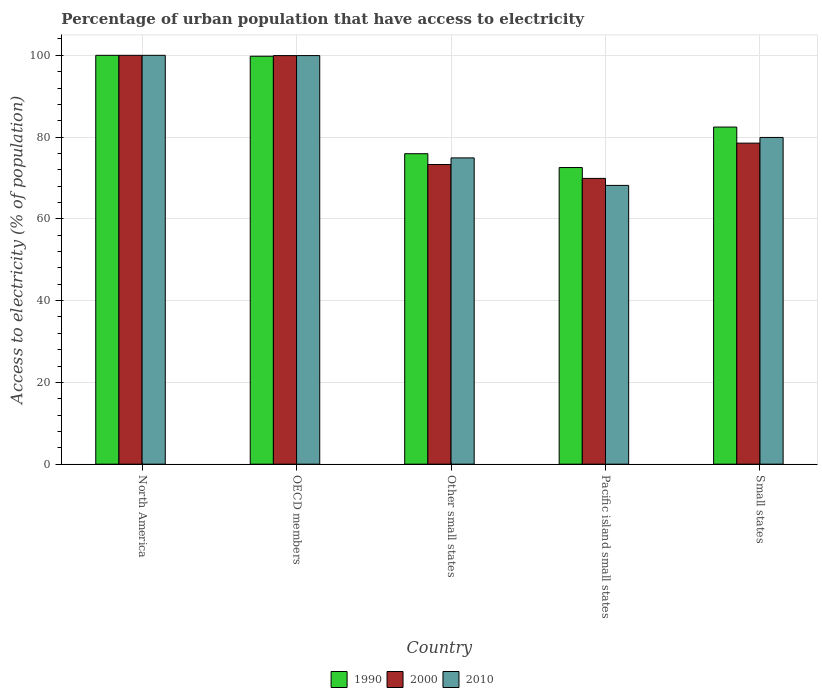How many different coloured bars are there?
Offer a terse response. 3. How many groups of bars are there?
Keep it short and to the point. 5. How many bars are there on the 4th tick from the left?
Offer a very short reply. 3. How many bars are there on the 1st tick from the right?
Your answer should be very brief. 3. What is the percentage of urban population that have access to electricity in 2000 in Pacific island small states?
Provide a succinct answer. 69.89. Across all countries, what is the minimum percentage of urban population that have access to electricity in 1990?
Make the answer very short. 72.55. In which country was the percentage of urban population that have access to electricity in 1990 maximum?
Your answer should be compact. North America. In which country was the percentage of urban population that have access to electricity in 1990 minimum?
Your response must be concise. Pacific island small states. What is the total percentage of urban population that have access to electricity in 2010 in the graph?
Offer a very short reply. 422.94. What is the difference between the percentage of urban population that have access to electricity in 2010 in Other small states and that in Pacific island small states?
Keep it short and to the point. 6.72. What is the difference between the percentage of urban population that have access to electricity in 2000 in North America and the percentage of urban population that have access to electricity in 2010 in Pacific island small states?
Your answer should be very brief. 31.82. What is the average percentage of urban population that have access to electricity in 1990 per country?
Ensure brevity in your answer.  86.14. What is the difference between the percentage of urban population that have access to electricity of/in 2010 and percentage of urban population that have access to electricity of/in 1990 in Other small states?
Give a very brief answer. -1.02. In how many countries, is the percentage of urban population that have access to electricity in 2010 greater than 88 %?
Your response must be concise. 2. What is the ratio of the percentage of urban population that have access to electricity in 2000 in North America to that in OECD members?
Give a very brief answer. 1. Is the percentage of urban population that have access to electricity in 2000 in OECD members less than that in Other small states?
Your response must be concise. No. What is the difference between the highest and the second highest percentage of urban population that have access to electricity in 2000?
Ensure brevity in your answer.  -0.07. What is the difference between the highest and the lowest percentage of urban population that have access to electricity in 2010?
Your response must be concise. 31.82. In how many countries, is the percentage of urban population that have access to electricity in 1990 greater than the average percentage of urban population that have access to electricity in 1990 taken over all countries?
Ensure brevity in your answer.  2. Is the sum of the percentage of urban population that have access to electricity in 2010 in OECD members and Other small states greater than the maximum percentage of urban population that have access to electricity in 1990 across all countries?
Offer a terse response. Yes. Is it the case that in every country, the sum of the percentage of urban population that have access to electricity in 2010 and percentage of urban population that have access to electricity in 1990 is greater than the percentage of urban population that have access to electricity in 2000?
Give a very brief answer. Yes. How many bars are there?
Keep it short and to the point. 15. Are all the bars in the graph horizontal?
Make the answer very short. No. How many countries are there in the graph?
Your answer should be very brief. 5. Are the values on the major ticks of Y-axis written in scientific E-notation?
Offer a very short reply. No. Does the graph contain any zero values?
Your answer should be compact. No. Does the graph contain grids?
Offer a terse response. Yes. Where does the legend appear in the graph?
Give a very brief answer. Bottom center. How many legend labels are there?
Ensure brevity in your answer.  3. How are the legend labels stacked?
Offer a terse response. Horizontal. What is the title of the graph?
Provide a succinct answer. Percentage of urban population that have access to electricity. Does "1973" appear as one of the legend labels in the graph?
Give a very brief answer. No. What is the label or title of the X-axis?
Give a very brief answer. Country. What is the label or title of the Y-axis?
Offer a very short reply. Access to electricity (% of population). What is the Access to electricity (% of population) of 1990 in OECD members?
Provide a short and direct response. 99.78. What is the Access to electricity (% of population) in 2000 in OECD members?
Offer a very short reply. 99.93. What is the Access to electricity (% of population) of 2010 in OECD members?
Keep it short and to the point. 99.93. What is the Access to electricity (% of population) of 1990 in Other small states?
Ensure brevity in your answer.  75.93. What is the Access to electricity (% of population) of 2000 in Other small states?
Give a very brief answer. 73.29. What is the Access to electricity (% of population) of 2010 in Other small states?
Ensure brevity in your answer.  74.91. What is the Access to electricity (% of population) of 1990 in Pacific island small states?
Provide a succinct answer. 72.55. What is the Access to electricity (% of population) of 2000 in Pacific island small states?
Ensure brevity in your answer.  69.89. What is the Access to electricity (% of population) of 2010 in Pacific island small states?
Offer a very short reply. 68.18. What is the Access to electricity (% of population) of 1990 in Small states?
Your answer should be compact. 82.45. What is the Access to electricity (% of population) of 2000 in Small states?
Give a very brief answer. 78.52. What is the Access to electricity (% of population) of 2010 in Small states?
Provide a short and direct response. 79.91. Across all countries, what is the maximum Access to electricity (% of population) in 2000?
Offer a very short reply. 100. Across all countries, what is the maximum Access to electricity (% of population) in 2010?
Make the answer very short. 100. Across all countries, what is the minimum Access to electricity (% of population) of 1990?
Give a very brief answer. 72.55. Across all countries, what is the minimum Access to electricity (% of population) in 2000?
Your response must be concise. 69.89. Across all countries, what is the minimum Access to electricity (% of population) in 2010?
Offer a terse response. 68.18. What is the total Access to electricity (% of population) of 1990 in the graph?
Offer a terse response. 430.71. What is the total Access to electricity (% of population) in 2000 in the graph?
Offer a very short reply. 421.64. What is the total Access to electricity (% of population) of 2010 in the graph?
Make the answer very short. 422.94. What is the difference between the Access to electricity (% of population) of 1990 in North America and that in OECD members?
Provide a short and direct response. 0.22. What is the difference between the Access to electricity (% of population) in 2000 in North America and that in OECD members?
Your answer should be compact. 0.07. What is the difference between the Access to electricity (% of population) in 2010 in North America and that in OECD members?
Your answer should be compact. 0.07. What is the difference between the Access to electricity (% of population) in 1990 in North America and that in Other small states?
Ensure brevity in your answer.  24.07. What is the difference between the Access to electricity (% of population) in 2000 in North America and that in Other small states?
Keep it short and to the point. 26.71. What is the difference between the Access to electricity (% of population) in 2010 in North America and that in Other small states?
Ensure brevity in your answer.  25.09. What is the difference between the Access to electricity (% of population) of 1990 in North America and that in Pacific island small states?
Offer a terse response. 27.45. What is the difference between the Access to electricity (% of population) in 2000 in North America and that in Pacific island small states?
Keep it short and to the point. 30.11. What is the difference between the Access to electricity (% of population) of 2010 in North America and that in Pacific island small states?
Provide a succinct answer. 31.82. What is the difference between the Access to electricity (% of population) of 1990 in North America and that in Small states?
Ensure brevity in your answer.  17.55. What is the difference between the Access to electricity (% of population) in 2000 in North America and that in Small states?
Ensure brevity in your answer.  21.48. What is the difference between the Access to electricity (% of population) of 2010 in North America and that in Small states?
Keep it short and to the point. 20.09. What is the difference between the Access to electricity (% of population) in 1990 in OECD members and that in Other small states?
Provide a succinct answer. 23.85. What is the difference between the Access to electricity (% of population) in 2000 in OECD members and that in Other small states?
Your answer should be compact. 26.64. What is the difference between the Access to electricity (% of population) of 2010 in OECD members and that in Other small states?
Your answer should be very brief. 25.03. What is the difference between the Access to electricity (% of population) in 1990 in OECD members and that in Pacific island small states?
Provide a succinct answer. 27.23. What is the difference between the Access to electricity (% of population) of 2000 in OECD members and that in Pacific island small states?
Provide a short and direct response. 30.04. What is the difference between the Access to electricity (% of population) of 2010 in OECD members and that in Pacific island small states?
Ensure brevity in your answer.  31.75. What is the difference between the Access to electricity (% of population) of 1990 in OECD members and that in Small states?
Give a very brief answer. 17.33. What is the difference between the Access to electricity (% of population) in 2000 in OECD members and that in Small states?
Ensure brevity in your answer.  21.41. What is the difference between the Access to electricity (% of population) of 2010 in OECD members and that in Small states?
Give a very brief answer. 20.02. What is the difference between the Access to electricity (% of population) of 1990 in Other small states and that in Pacific island small states?
Give a very brief answer. 3.38. What is the difference between the Access to electricity (% of population) of 2000 in Other small states and that in Pacific island small states?
Your answer should be compact. 3.4. What is the difference between the Access to electricity (% of population) of 2010 in Other small states and that in Pacific island small states?
Keep it short and to the point. 6.72. What is the difference between the Access to electricity (% of population) of 1990 in Other small states and that in Small states?
Your response must be concise. -6.52. What is the difference between the Access to electricity (% of population) in 2000 in Other small states and that in Small states?
Offer a very short reply. -5.23. What is the difference between the Access to electricity (% of population) in 2010 in Other small states and that in Small states?
Make the answer very short. -5. What is the difference between the Access to electricity (% of population) in 1990 in Pacific island small states and that in Small states?
Provide a short and direct response. -9.9. What is the difference between the Access to electricity (% of population) of 2000 in Pacific island small states and that in Small states?
Your response must be concise. -8.63. What is the difference between the Access to electricity (% of population) in 2010 in Pacific island small states and that in Small states?
Give a very brief answer. -11.73. What is the difference between the Access to electricity (% of population) in 1990 in North America and the Access to electricity (% of population) in 2000 in OECD members?
Offer a very short reply. 0.07. What is the difference between the Access to electricity (% of population) of 1990 in North America and the Access to electricity (% of population) of 2010 in OECD members?
Provide a short and direct response. 0.07. What is the difference between the Access to electricity (% of population) of 2000 in North America and the Access to electricity (% of population) of 2010 in OECD members?
Provide a succinct answer. 0.07. What is the difference between the Access to electricity (% of population) of 1990 in North America and the Access to electricity (% of population) of 2000 in Other small states?
Your answer should be compact. 26.71. What is the difference between the Access to electricity (% of population) of 1990 in North America and the Access to electricity (% of population) of 2010 in Other small states?
Your response must be concise. 25.09. What is the difference between the Access to electricity (% of population) of 2000 in North America and the Access to electricity (% of population) of 2010 in Other small states?
Ensure brevity in your answer.  25.09. What is the difference between the Access to electricity (% of population) in 1990 in North America and the Access to electricity (% of population) in 2000 in Pacific island small states?
Offer a very short reply. 30.11. What is the difference between the Access to electricity (% of population) in 1990 in North America and the Access to electricity (% of population) in 2010 in Pacific island small states?
Your answer should be very brief. 31.82. What is the difference between the Access to electricity (% of population) of 2000 in North America and the Access to electricity (% of population) of 2010 in Pacific island small states?
Provide a succinct answer. 31.82. What is the difference between the Access to electricity (% of population) of 1990 in North America and the Access to electricity (% of population) of 2000 in Small states?
Provide a short and direct response. 21.48. What is the difference between the Access to electricity (% of population) in 1990 in North America and the Access to electricity (% of population) in 2010 in Small states?
Provide a succinct answer. 20.09. What is the difference between the Access to electricity (% of population) in 2000 in North America and the Access to electricity (% of population) in 2010 in Small states?
Provide a short and direct response. 20.09. What is the difference between the Access to electricity (% of population) in 1990 in OECD members and the Access to electricity (% of population) in 2000 in Other small states?
Your response must be concise. 26.49. What is the difference between the Access to electricity (% of population) of 1990 in OECD members and the Access to electricity (% of population) of 2010 in Other small states?
Offer a terse response. 24.87. What is the difference between the Access to electricity (% of population) in 2000 in OECD members and the Access to electricity (% of population) in 2010 in Other small states?
Provide a short and direct response. 25.02. What is the difference between the Access to electricity (% of population) of 1990 in OECD members and the Access to electricity (% of population) of 2000 in Pacific island small states?
Keep it short and to the point. 29.88. What is the difference between the Access to electricity (% of population) of 1990 in OECD members and the Access to electricity (% of population) of 2010 in Pacific island small states?
Your response must be concise. 31.59. What is the difference between the Access to electricity (% of population) in 2000 in OECD members and the Access to electricity (% of population) in 2010 in Pacific island small states?
Keep it short and to the point. 31.75. What is the difference between the Access to electricity (% of population) of 1990 in OECD members and the Access to electricity (% of population) of 2000 in Small states?
Offer a terse response. 21.26. What is the difference between the Access to electricity (% of population) of 1990 in OECD members and the Access to electricity (% of population) of 2010 in Small states?
Offer a terse response. 19.87. What is the difference between the Access to electricity (% of population) in 2000 in OECD members and the Access to electricity (% of population) in 2010 in Small states?
Your answer should be compact. 20.02. What is the difference between the Access to electricity (% of population) of 1990 in Other small states and the Access to electricity (% of population) of 2000 in Pacific island small states?
Provide a succinct answer. 6.04. What is the difference between the Access to electricity (% of population) in 1990 in Other small states and the Access to electricity (% of population) in 2010 in Pacific island small states?
Give a very brief answer. 7.75. What is the difference between the Access to electricity (% of population) in 2000 in Other small states and the Access to electricity (% of population) in 2010 in Pacific island small states?
Give a very brief answer. 5.11. What is the difference between the Access to electricity (% of population) of 1990 in Other small states and the Access to electricity (% of population) of 2000 in Small states?
Provide a short and direct response. -2.59. What is the difference between the Access to electricity (% of population) of 1990 in Other small states and the Access to electricity (% of population) of 2010 in Small states?
Provide a succinct answer. -3.98. What is the difference between the Access to electricity (% of population) of 2000 in Other small states and the Access to electricity (% of population) of 2010 in Small states?
Offer a very short reply. -6.62. What is the difference between the Access to electricity (% of population) in 1990 in Pacific island small states and the Access to electricity (% of population) in 2000 in Small states?
Give a very brief answer. -5.97. What is the difference between the Access to electricity (% of population) of 1990 in Pacific island small states and the Access to electricity (% of population) of 2010 in Small states?
Your answer should be compact. -7.36. What is the difference between the Access to electricity (% of population) of 2000 in Pacific island small states and the Access to electricity (% of population) of 2010 in Small states?
Provide a short and direct response. -10.02. What is the average Access to electricity (% of population) of 1990 per country?
Provide a short and direct response. 86.14. What is the average Access to electricity (% of population) of 2000 per country?
Keep it short and to the point. 84.33. What is the average Access to electricity (% of population) in 2010 per country?
Make the answer very short. 84.59. What is the difference between the Access to electricity (% of population) of 1990 and Access to electricity (% of population) of 2000 in North America?
Your response must be concise. 0. What is the difference between the Access to electricity (% of population) in 1990 and Access to electricity (% of population) in 2010 in North America?
Your response must be concise. 0. What is the difference between the Access to electricity (% of population) of 1990 and Access to electricity (% of population) of 2000 in OECD members?
Provide a succinct answer. -0.15. What is the difference between the Access to electricity (% of population) in 1990 and Access to electricity (% of population) in 2010 in OECD members?
Your answer should be compact. -0.15. What is the difference between the Access to electricity (% of population) of 2000 and Access to electricity (% of population) of 2010 in OECD members?
Make the answer very short. -0. What is the difference between the Access to electricity (% of population) in 1990 and Access to electricity (% of population) in 2000 in Other small states?
Provide a short and direct response. 2.64. What is the difference between the Access to electricity (% of population) of 1990 and Access to electricity (% of population) of 2010 in Other small states?
Keep it short and to the point. 1.02. What is the difference between the Access to electricity (% of population) in 2000 and Access to electricity (% of population) in 2010 in Other small states?
Your answer should be compact. -1.62. What is the difference between the Access to electricity (% of population) in 1990 and Access to electricity (% of population) in 2000 in Pacific island small states?
Offer a terse response. 2.66. What is the difference between the Access to electricity (% of population) of 1990 and Access to electricity (% of population) of 2010 in Pacific island small states?
Your response must be concise. 4.37. What is the difference between the Access to electricity (% of population) in 2000 and Access to electricity (% of population) in 2010 in Pacific island small states?
Make the answer very short. 1.71. What is the difference between the Access to electricity (% of population) of 1990 and Access to electricity (% of population) of 2000 in Small states?
Give a very brief answer. 3.93. What is the difference between the Access to electricity (% of population) of 1990 and Access to electricity (% of population) of 2010 in Small states?
Give a very brief answer. 2.54. What is the difference between the Access to electricity (% of population) of 2000 and Access to electricity (% of population) of 2010 in Small states?
Ensure brevity in your answer.  -1.39. What is the ratio of the Access to electricity (% of population) in 1990 in North America to that in OECD members?
Your answer should be very brief. 1. What is the ratio of the Access to electricity (% of population) in 2000 in North America to that in OECD members?
Provide a short and direct response. 1. What is the ratio of the Access to electricity (% of population) in 1990 in North America to that in Other small states?
Provide a succinct answer. 1.32. What is the ratio of the Access to electricity (% of population) in 2000 in North America to that in Other small states?
Provide a short and direct response. 1.36. What is the ratio of the Access to electricity (% of population) of 2010 in North America to that in Other small states?
Provide a succinct answer. 1.33. What is the ratio of the Access to electricity (% of population) of 1990 in North America to that in Pacific island small states?
Make the answer very short. 1.38. What is the ratio of the Access to electricity (% of population) of 2000 in North America to that in Pacific island small states?
Make the answer very short. 1.43. What is the ratio of the Access to electricity (% of population) of 2010 in North America to that in Pacific island small states?
Your answer should be very brief. 1.47. What is the ratio of the Access to electricity (% of population) of 1990 in North America to that in Small states?
Keep it short and to the point. 1.21. What is the ratio of the Access to electricity (% of population) in 2000 in North America to that in Small states?
Your answer should be compact. 1.27. What is the ratio of the Access to electricity (% of population) of 2010 in North America to that in Small states?
Keep it short and to the point. 1.25. What is the ratio of the Access to electricity (% of population) of 1990 in OECD members to that in Other small states?
Provide a succinct answer. 1.31. What is the ratio of the Access to electricity (% of population) in 2000 in OECD members to that in Other small states?
Your answer should be very brief. 1.36. What is the ratio of the Access to electricity (% of population) in 2010 in OECD members to that in Other small states?
Your response must be concise. 1.33. What is the ratio of the Access to electricity (% of population) in 1990 in OECD members to that in Pacific island small states?
Offer a terse response. 1.38. What is the ratio of the Access to electricity (% of population) of 2000 in OECD members to that in Pacific island small states?
Ensure brevity in your answer.  1.43. What is the ratio of the Access to electricity (% of population) of 2010 in OECD members to that in Pacific island small states?
Ensure brevity in your answer.  1.47. What is the ratio of the Access to electricity (% of population) of 1990 in OECD members to that in Small states?
Provide a short and direct response. 1.21. What is the ratio of the Access to electricity (% of population) in 2000 in OECD members to that in Small states?
Provide a succinct answer. 1.27. What is the ratio of the Access to electricity (% of population) in 2010 in OECD members to that in Small states?
Offer a very short reply. 1.25. What is the ratio of the Access to electricity (% of population) in 1990 in Other small states to that in Pacific island small states?
Your answer should be very brief. 1.05. What is the ratio of the Access to electricity (% of population) of 2000 in Other small states to that in Pacific island small states?
Make the answer very short. 1.05. What is the ratio of the Access to electricity (% of population) in 2010 in Other small states to that in Pacific island small states?
Your answer should be very brief. 1.1. What is the ratio of the Access to electricity (% of population) in 1990 in Other small states to that in Small states?
Provide a succinct answer. 0.92. What is the ratio of the Access to electricity (% of population) of 2000 in Other small states to that in Small states?
Offer a terse response. 0.93. What is the ratio of the Access to electricity (% of population) in 2010 in Other small states to that in Small states?
Give a very brief answer. 0.94. What is the ratio of the Access to electricity (% of population) of 1990 in Pacific island small states to that in Small states?
Your answer should be compact. 0.88. What is the ratio of the Access to electricity (% of population) of 2000 in Pacific island small states to that in Small states?
Provide a succinct answer. 0.89. What is the ratio of the Access to electricity (% of population) of 2010 in Pacific island small states to that in Small states?
Provide a succinct answer. 0.85. What is the difference between the highest and the second highest Access to electricity (% of population) of 1990?
Give a very brief answer. 0.22. What is the difference between the highest and the second highest Access to electricity (% of population) of 2000?
Ensure brevity in your answer.  0.07. What is the difference between the highest and the second highest Access to electricity (% of population) of 2010?
Keep it short and to the point. 0.07. What is the difference between the highest and the lowest Access to electricity (% of population) of 1990?
Provide a short and direct response. 27.45. What is the difference between the highest and the lowest Access to electricity (% of population) in 2000?
Provide a succinct answer. 30.11. What is the difference between the highest and the lowest Access to electricity (% of population) in 2010?
Your answer should be compact. 31.82. 